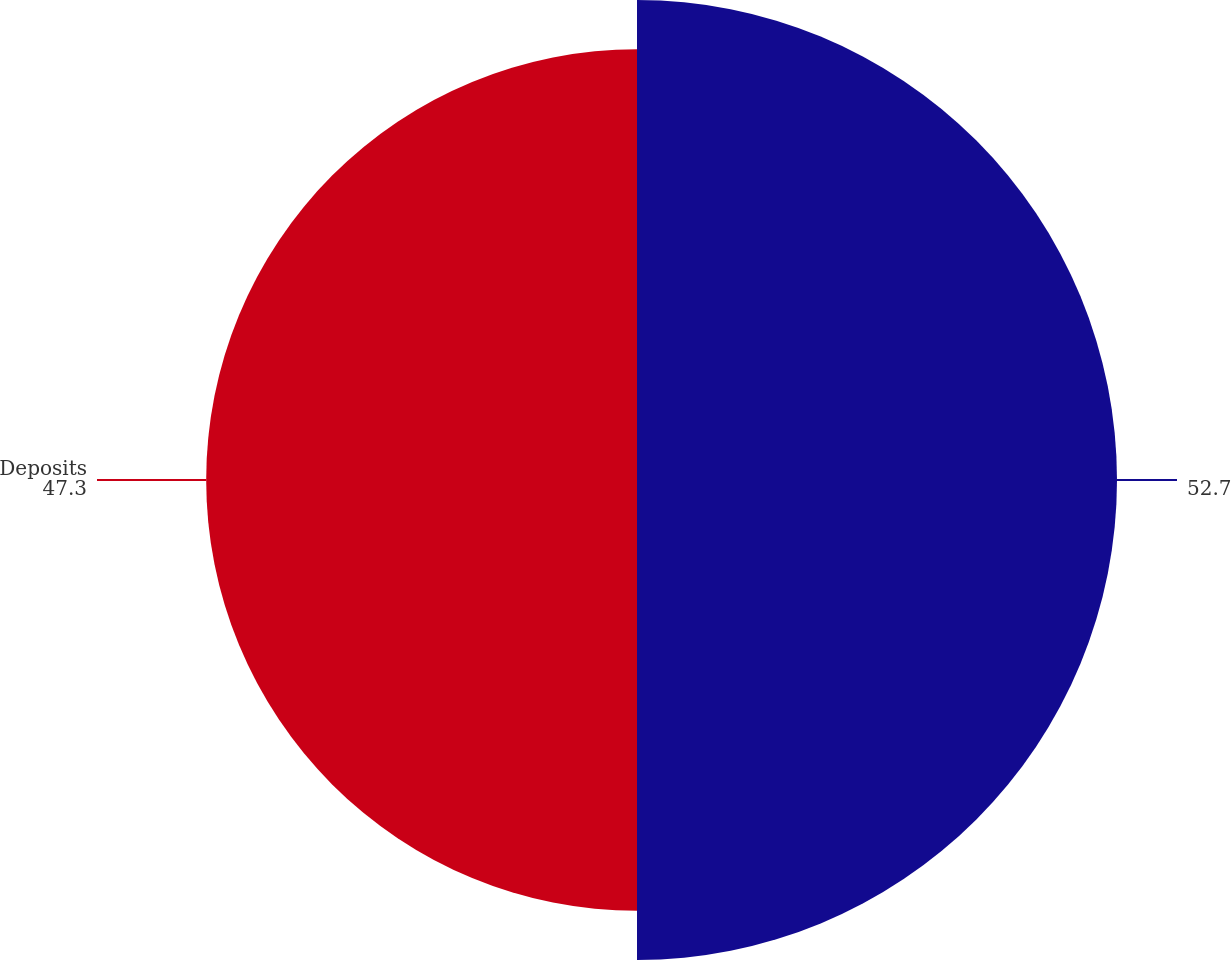Convert chart. <chart><loc_0><loc_0><loc_500><loc_500><pie_chart><ecel><fcel>Deposits<nl><fcel>52.7%<fcel>47.3%<nl></chart> 